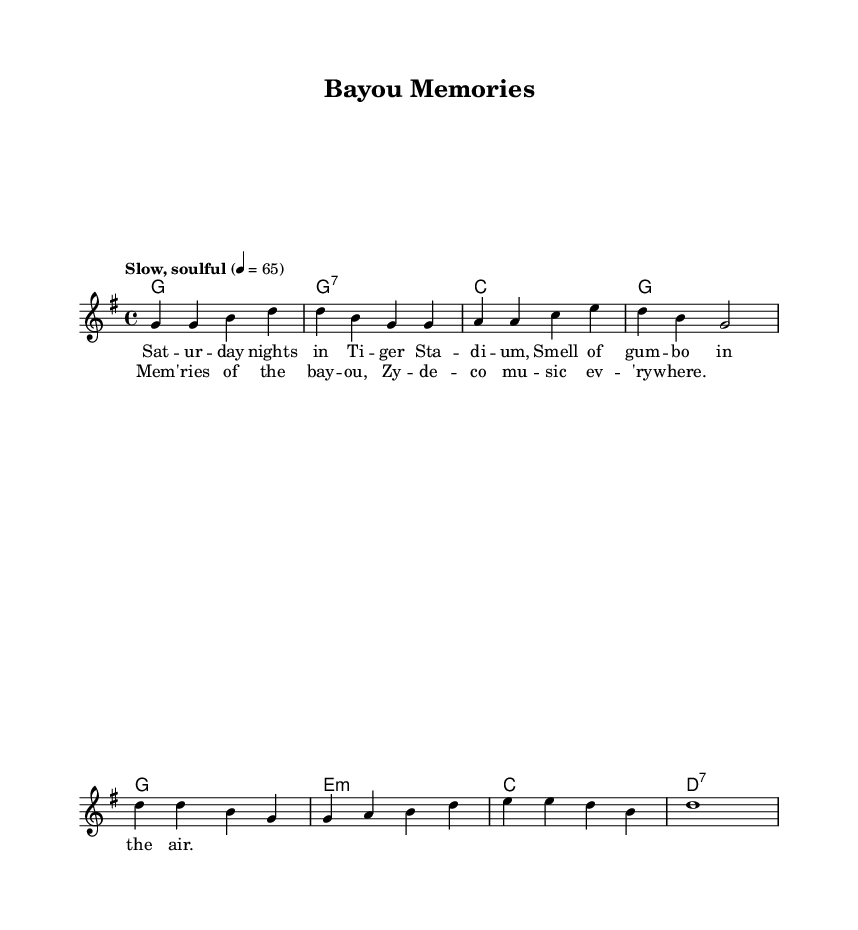What is the key signature of this music? The key signature is G major, which has one sharp (F#).
Answer: G major What is the time signature of the piece? The time signature is 4/4, which means there are four beats per measure and the quarter note gets one beat.
Answer: 4/4 What is the tempo marking for the piece? The tempo marking is "Slow, soulful," indicating that the piece should be played at a relaxed pace.
Answer: Slow, soulful How many measures are in the verse section? The verse section contains four measures, as indicated by the grouping of the notes and chords before transitioning to the chorus.
Answer: 4 What type of music is this piece classified as? This piece is classified as Rhythm and Blues, particularly reflecting Southern soul music through its themes and structure.
Answer: Rhythm and Blues What is the primary theme reflected in the lyrics? The primary theme reflected in the lyrics is nostalgia, focusing on memories associated with Louisiana culture.
Answer: Nostalgia Which musical element includes both melody and harmony in this score? The musical element that includes both melody and harmony is the score, which uniquely combines the lead melody and the accompanying chords.
Answer: Score 